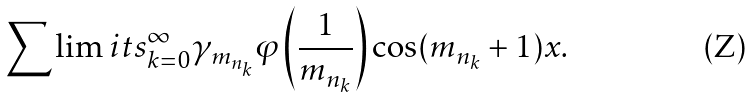Convert formula to latex. <formula><loc_0><loc_0><loc_500><loc_500>\sum \lim i t s _ { k = 0 } ^ { \infty } { \gamma _ { m _ { n _ { k } } } } \varphi \left ( \frac { 1 } { m _ { n _ { k } } } \right ) \cos ( { m _ { n _ { k } } } + 1 ) x .</formula> 